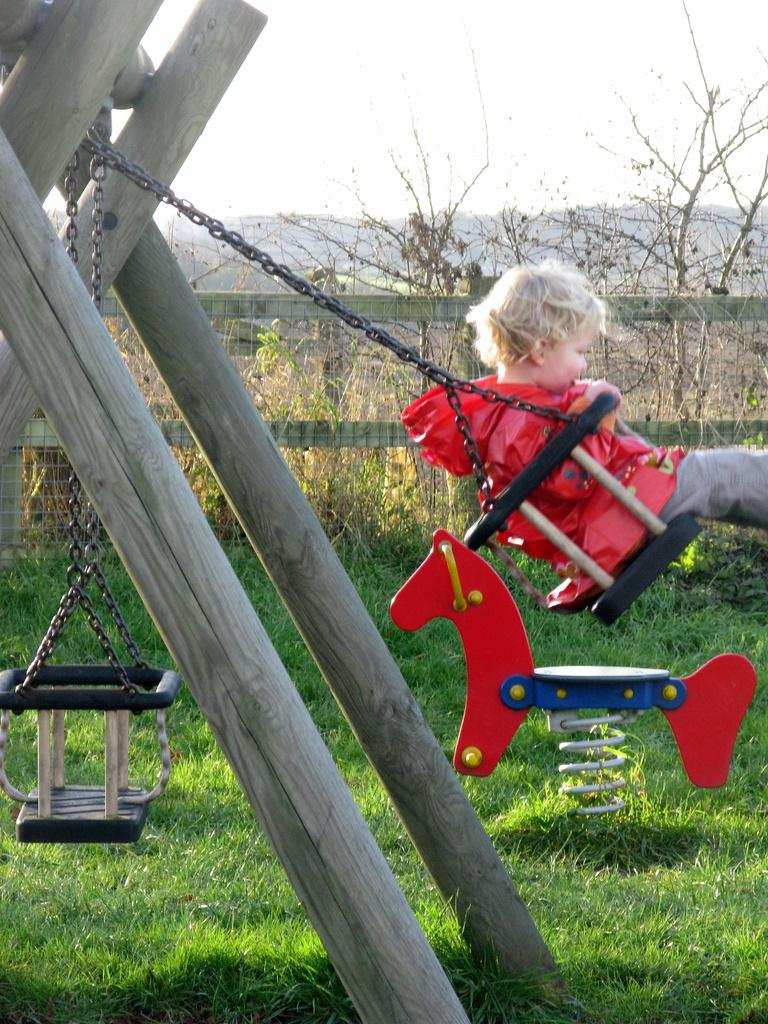What is the main subject of the image? The main subject of the image is a kid. What is the kid wearing? The kid is wearing a red jacket. What activity is the kid engaged in? The kid is playing on a toddler swing. What can be seen in the background of the image? There is fencing and trees in the background of the image, and the sky is clear and visible. What type of crime is being committed in the image? There is no indication of any crime being committed in the image; it features a kid playing on a swing. What type of bat is visible in the image? There is no bat, either animal or sports equipment, present in the image. 